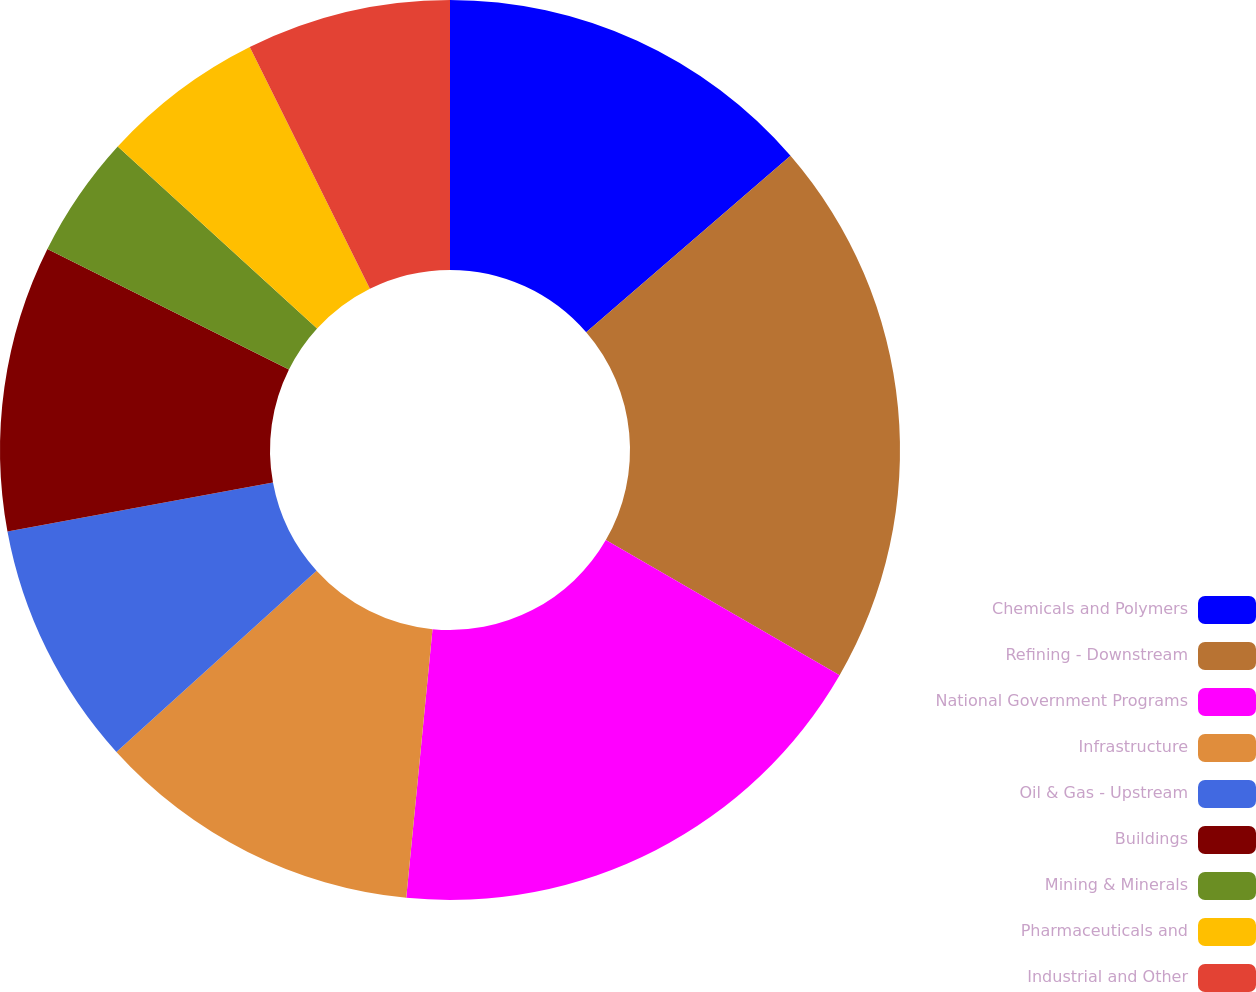<chart> <loc_0><loc_0><loc_500><loc_500><pie_chart><fcel>Chemicals and Polymers<fcel>Refining - Downstream<fcel>National Government Programs<fcel>Infrastructure<fcel>Oil & Gas - Upstream<fcel>Buildings<fcel>Mining & Minerals<fcel>Pharmaceuticals and<fcel>Industrial and Other<nl><fcel>13.66%<fcel>19.68%<fcel>18.21%<fcel>11.74%<fcel>8.81%<fcel>10.27%<fcel>4.41%<fcel>5.88%<fcel>7.34%<nl></chart> 